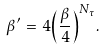<formula> <loc_0><loc_0><loc_500><loc_500>\beta ^ { \prime } \, = \, 4 { \left ( \frac { \beta } { 4 } \right ) } ^ { N _ { \tau } } .</formula> 